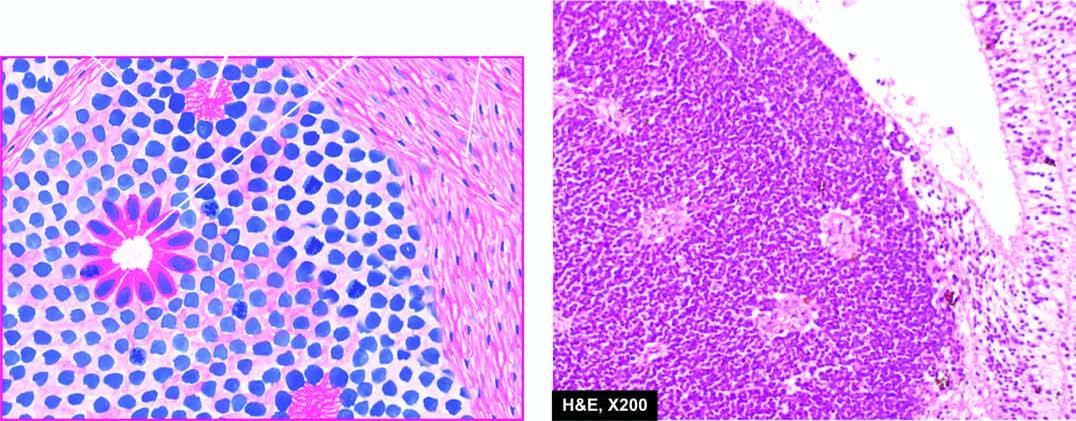does the tumour arising from the retina show undifferentiated retinal cells and the typical rosettes?
Answer the question using a single word or phrase. Yes 